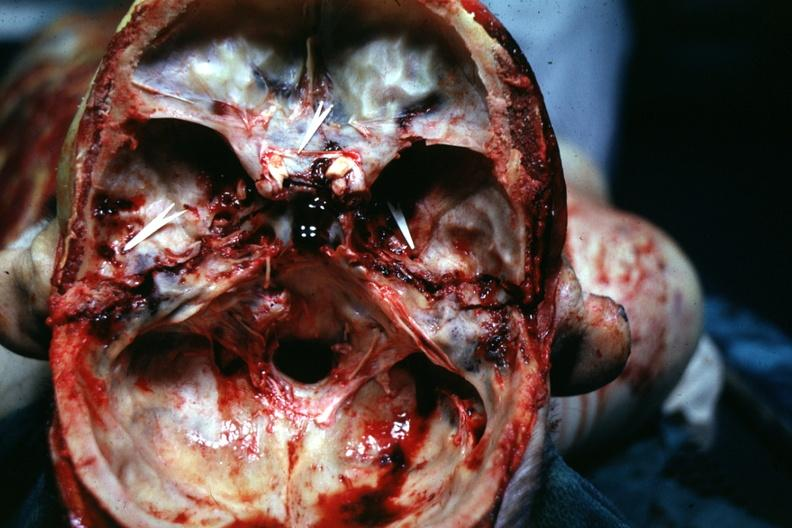does this image show bilateral?
Answer the question using a single word or phrase. Yes 